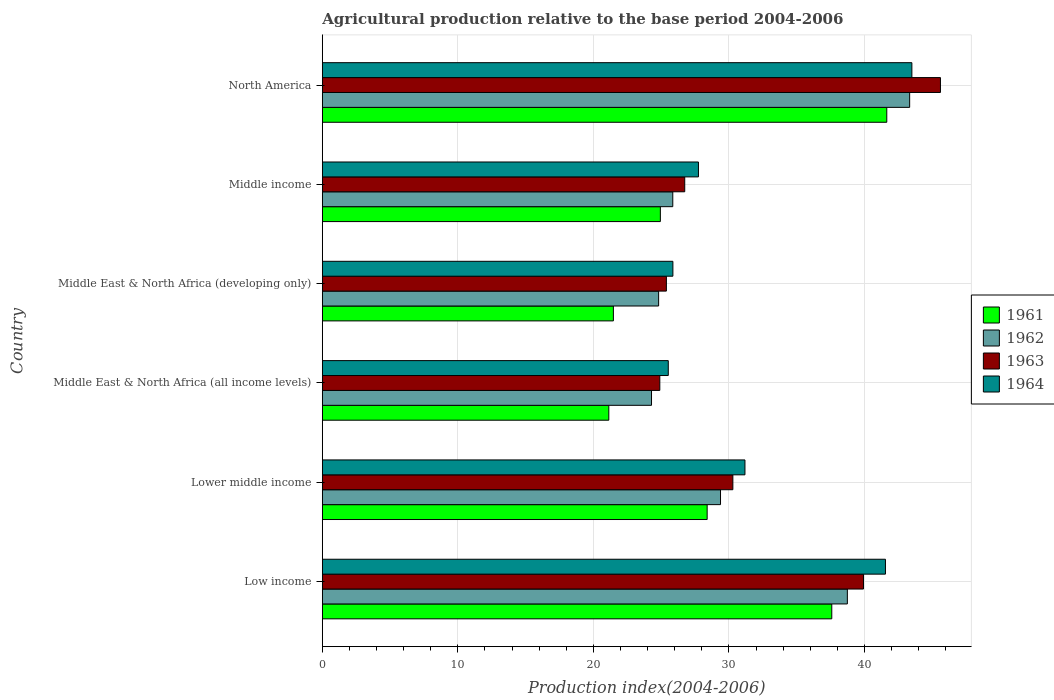How many bars are there on the 6th tick from the top?
Make the answer very short. 4. What is the label of the 2nd group of bars from the top?
Offer a terse response. Middle income. In how many cases, is the number of bars for a given country not equal to the number of legend labels?
Provide a succinct answer. 0. What is the agricultural production index in 1963 in Middle East & North Africa (all income levels)?
Keep it short and to the point. 24.9. Across all countries, what is the maximum agricultural production index in 1961?
Offer a very short reply. 41.65. Across all countries, what is the minimum agricultural production index in 1964?
Your answer should be compact. 25.53. In which country was the agricultural production index in 1964 maximum?
Provide a short and direct response. North America. In which country was the agricultural production index in 1963 minimum?
Make the answer very short. Middle East & North Africa (all income levels). What is the total agricultural production index in 1964 in the graph?
Provide a succinct answer. 195.37. What is the difference between the agricultural production index in 1964 in Middle income and that in North America?
Your response must be concise. -15.75. What is the difference between the agricultural production index in 1963 in Middle income and the agricultural production index in 1962 in Low income?
Ensure brevity in your answer.  -12. What is the average agricultural production index in 1963 per country?
Offer a terse response. 32.14. What is the difference between the agricultural production index in 1961 and agricultural production index in 1963 in Middle East & North Africa (all income levels)?
Provide a succinct answer. -3.76. In how many countries, is the agricultural production index in 1961 greater than 24 ?
Offer a very short reply. 4. What is the ratio of the agricultural production index in 1961 in Low income to that in Middle East & North Africa (all income levels)?
Provide a succinct answer. 1.78. Is the agricultural production index in 1963 in Middle East & North Africa (developing only) less than that in Middle income?
Provide a short and direct response. Yes. What is the difference between the highest and the second highest agricultural production index in 1964?
Offer a terse response. 1.95. What is the difference between the highest and the lowest agricultural production index in 1964?
Your answer should be very brief. 17.97. In how many countries, is the agricultural production index in 1963 greater than the average agricultural production index in 1963 taken over all countries?
Ensure brevity in your answer.  2. Is it the case that in every country, the sum of the agricultural production index in 1961 and agricultural production index in 1963 is greater than the sum of agricultural production index in 1964 and agricultural production index in 1962?
Give a very brief answer. No. What does the 1st bar from the top in Middle East & North Africa (developing only) represents?
Make the answer very short. 1964. What does the 2nd bar from the bottom in North America represents?
Make the answer very short. 1962. Is it the case that in every country, the sum of the agricultural production index in 1961 and agricultural production index in 1964 is greater than the agricultural production index in 1963?
Your answer should be compact. Yes. How many countries are there in the graph?
Offer a terse response. 6. Are the values on the major ticks of X-axis written in scientific E-notation?
Make the answer very short. No. Does the graph contain grids?
Make the answer very short. Yes. What is the title of the graph?
Offer a terse response. Agricultural production relative to the base period 2004-2006. Does "2003" appear as one of the legend labels in the graph?
Provide a succinct answer. No. What is the label or title of the X-axis?
Provide a short and direct response. Production index(2004-2006). What is the label or title of the Y-axis?
Your answer should be very brief. Country. What is the Production index(2004-2006) of 1961 in Low income?
Ensure brevity in your answer.  37.59. What is the Production index(2004-2006) in 1962 in Low income?
Keep it short and to the point. 38.74. What is the Production index(2004-2006) of 1963 in Low income?
Your answer should be very brief. 39.93. What is the Production index(2004-2006) of 1964 in Low income?
Provide a short and direct response. 41.55. What is the Production index(2004-2006) in 1961 in Lower middle income?
Provide a succinct answer. 28.39. What is the Production index(2004-2006) of 1962 in Lower middle income?
Provide a short and direct response. 29.38. What is the Production index(2004-2006) in 1963 in Lower middle income?
Your answer should be compact. 30.29. What is the Production index(2004-2006) in 1964 in Lower middle income?
Provide a short and direct response. 31.18. What is the Production index(2004-2006) of 1961 in Middle East & North Africa (all income levels)?
Ensure brevity in your answer.  21.14. What is the Production index(2004-2006) in 1962 in Middle East & North Africa (all income levels)?
Offer a very short reply. 24.29. What is the Production index(2004-2006) in 1963 in Middle East & North Africa (all income levels)?
Make the answer very short. 24.9. What is the Production index(2004-2006) in 1964 in Middle East & North Africa (all income levels)?
Provide a short and direct response. 25.53. What is the Production index(2004-2006) of 1961 in Middle East & North Africa (developing only)?
Offer a very short reply. 21.48. What is the Production index(2004-2006) of 1962 in Middle East & North Africa (developing only)?
Provide a short and direct response. 24.81. What is the Production index(2004-2006) of 1963 in Middle East & North Africa (developing only)?
Keep it short and to the point. 25.39. What is the Production index(2004-2006) in 1964 in Middle East & North Africa (developing only)?
Ensure brevity in your answer.  25.86. What is the Production index(2004-2006) in 1961 in Middle income?
Provide a short and direct response. 24.94. What is the Production index(2004-2006) in 1962 in Middle income?
Your response must be concise. 25.86. What is the Production index(2004-2006) in 1963 in Middle income?
Your answer should be compact. 26.74. What is the Production index(2004-2006) of 1964 in Middle income?
Give a very brief answer. 27.75. What is the Production index(2004-2006) of 1961 in North America?
Give a very brief answer. 41.65. What is the Production index(2004-2006) of 1962 in North America?
Provide a short and direct response. 43.33. What is the Production index(2004-2006) in 1963 in North America?
Make the answer very short. 45.61. What is the Production index(2004-2006) of 1964 in North America?
Provide a short and direct response. 43.5. Across all countries, what is the maximum Production index(2004-2006) of 1961?
Make the answer very short. 41.65. Across all countries, what is the maximum Production index(2004-2006) of 1962?
Your response must be concise. 43.33. Across all countries, what is the maximum Production index(2004-2006) of 1963?
Provide a short and direct response. 45.61. Across all countries, what is the maximum Production index(2004-2006) of 1964?
Your answer should be compact. 43.5. Across all countries, what is the minimum Production index(2004-2006) of 1961?
Offer a terse response. 21.14. Across all countries, what is the minimum Production index(2004-2006) of 1962?
Your answer should be very brief. 24.29. Across all countries, what is the minimum Production index(2004-2006) of 1963?
Your answer should be compact. 24.9. Across all countries, what is the minimum Production index(2004-2006) in 1964?
Give a very brief answer. 25.53. What is the total Production index(2004-2006) in 1961 in the graph?
Offer a very short reply. 175.18. What is the total Production index(2004-2006) of 1962 in the graph?
Make the answer very short. 186.41. What is the total Production index(2004-2006) in 1963 in the graph?
Ensure brevity in your answer.  192.85. What is the total Production index(2004-2006) of 1964 in the graph?
Provide a short and direct response. 195.37. What is the difference between the Production index(2004-2006) of 1961 in Low income and that in Lower middle income?
Offer a very short reply. 9.19. What is the difference between the Production index(2004-2006) of 1962 in Low income and that in Lower middle income?
Your answer should be compact. 9.36. What is the difference between the Production index(2004-2006) of 1963 in Low income and that in Lower middle income?
Ensure brevity in your answer.  9.64. What is the difference between the Production index(2004-2006) of 1964 in Low income and that in Lower middle income?
Your answer should be very brief. 10.37. What is the difference between the Production index(2004-2006) in 1961 in Low income and that in Middle East & North Africa (all income levels)?
Provide a succinct answer. 16.45. What is the difference between the Production index(2004-2006) of 1962 in Low income and that in Middle East & North Africa (all income levels)?
Ensure brevity in your answer.  14.45. What is the difference between the Production index(2004-2006) of 1963 in Low income and that in Middle East & North Africa (all income levels)?
Your answer should be compact. 15.03. What is the difference between the Production index(2004-2006) in 1964 in Low income and that in Middle East & North Africa (all income levels)?
Keep it short and to the point. 16.02. What is the difference between the Production index(2004-2006) of 1961 in Low income and that in Middle East & North Africa (developing only)?
Your answer should be compact. 16.11. What is the difference between the Production index(2004-2006) of 1962 in Low income and that in Middle East & North Africa (developing only)?
Provide a short and direct response. 13.93. What is the difference between the Production index(2004-2006) in 1963 in Low income and that in Middle East & North Africa (developing only)?
Provide a short and direct response. 14.54. What is the difference between the Production index(2004-2006) in 1964 in Low income and that in Middle East & North Africa (developing only)?
Ensure brevity in your answer.  15.68. What is the difference between the Production index(2004-2006) in 1961 in Low income and that in Middle income?
Your answer should be compact. 12.65. What is the difference between the Production index(2004-2006) in 1962 in Low income and that in Middle income?
Make the answer very short. 12.88. What is the difference between the Production index(2004-2006) in 1963 in Low income and that in Middle income?
Your response must be concise. 13.19. What is the difference between the Production index(2004-2006) in 1964 in Low income and that in Middle income?
Your answer should be very brief. 13.8. What is the difference between the Production index(2004-2006) in 1961 in Low income and that in North America?
Provide a succinct answer. -4.06. What is the difference between the Production index(2004-2006) of 1962 in Low income and that in North America?
Offer a very short reply. -4.6. What is the difference between the Production index(2004-2006) in 1963 in Low income and that in North America?
Your response must be concise. -5.68. What is the difference between the Production index(2004-2006) of 1964 in Low income and that in North America?
Offer a very short reply. -1.95. What is the difference between the Production index(2004-2006) in 1961 in Lower middle income and that in Middle East & North Africa (all income levels)?
Keep it short and to the point. 7.26. What is the difference between the Production index(2004-2006) of 1962 in Lower middle income and that in Middle East & North Africa (all income levels)?
Ensure brevity in your answer.  5.09. What is the difference between the Production index(2004-2006) of 1963 in Lower middle income and that in Middle East & North Africa (all income levels)?
Your answer should be very brief. 5.39. What is the difference between the Production index(2004-2006) in 1964 in Lower middle income and that in Middle East & North Africa (all income levels)?
Offer a very short reply. 5.66. What is the difference between the Production index(2004-2006) in 1961 in Lower middle income and that in Middle East & North Africa (developing only)?
Provide a succinct answer. 6.92. What is the difference between the Production index(2004-2006) in 1962 in Lower middle income and that in Middle East & North Africa (developing only)?
Offer a very short reply. 4.57. What is the difference between the Production index(2004-2006) of 1963 in Lower middle income and that in Middle East & North Africa (developing only)?
Your answer should be very brief. 4.9. What is the difference between the Production index(2004-2006) in 1964 in Lower middle income and that in Middle East & North Africa (developing only)?
Your answer should be very brief. 5.32. What is the difference between the Production index(2004-2006) in 1961 in Lower middle income and that in Middle income?
Make the answer very short. 3.45. What is the difference between the Production index(2004-2006) of 1962 in Lower middle income and that in Middle income?
Provide a succinct answer. 3.52. What is the difference between the Production index(2004-2006) of 1963 in Lower middle income and that in Middle income?
Offer a very short reply. 3.55. What is the difference between the Production index(2004-2006) in 1964 in Lower middle income and that in Middle income?
Your answer should be very brief. 3.43. What is the difference between the Production index(2004-2006) in 1961 in Lower middle income and that in North America?
Your response must be concise. -13.25. What is the difference between the Production index(2004-2006) in 1962 in Lower middle income and that in North America?
Keep it short and to the point. -13.96. What is the difference between the Production index(2004-2006) of 1963 in Lower middle income and that in North America?
Ensure brevity in your answer.  -15.32. What is the difference between the Production index(2004-2006) of 1964 in Lower middle income and that in North America?
Offer a terse response. -12.32. What is the difference between the Production index(2004-2006) in 1961 in Middle East & North Africa (all income levels) and that in Middle East & North Africa (developing only)?
Offer a very short reply. -0.34. What is the difference between the Production index(2004-2006) in 1962 in Middle East & North Africa (all income levels) and that in Middle East & North Africa (developing only)?
Provide a succinct answer. -0.52. What is the difference between the Production index(2004-2006) in 1963 in Middle East & North Africa (all income levels) and that in Middle East & North Africa (developing only)?
Ensure brevity in your answer.  -0.48. What is the difference between the Production index(2004-2006) in 1964 in Middle East & North Africa (all income levels) and that in Middle East & North Africa (developing only)?
Offer a very short reply. -0.34. What is the difference between the Production index(2004-2006) of 1961 in Middle East & North Africa (all income levels) and that in Middle income?
Your answer should be very brief. -3.8. What is the difference between the Production index(2004-2006) in 1962 in Middle East & North Africa (all income levels) and that in Middle income?
Make the answer very short. -1.57. What is the difference between the Production index(2004-2006) in 1963 in Middle East & North Africa (all income levels) and that in Middle income?
Your response must be concise. -1.84. What is the difference between the Production index(2004-2006) of 1964 in Middle East & North Africa (all income levels) and that in Middle income?
Offer a very short reply. -2.23. What is the difference between the Production index(2004-2006) in 1961 in Middle East & North Africa (all income levels) and that in North America?
Your response must be concise. -20.51. What is the difference between the Production index(2004-2006) in 1962 in Middle East & North Africa (all income levels) and that in North America?
Provide a short and direct response. -19.05. What is the difference between the Production index(2004-2006) in 1963 in Middle East & North Africa (all income levels) and that in North America?
Your answer should be very brief. -20.71. What is the difference between the Production index(2004-2006) in 1964 in Middle East & North Africa (all income levels) and that in North America?
Give a very brief answer. -17.97. What is the difference between the Production index(2004-2006) in 1961 in Middle East & North Africa (developing only) and that in Middle income?
Provide a short and direct response. -3.47. What is the difference between the Production index(2004-2006) of 1962 in Middle East & North Africa (developing only) and that in Middle income?
Provide a succinct answer. -1.04. What is the difference between the Production index(2004-2006) of 1963 in Middle East & North Africa (developing only) and that in Middle income?
Offer a terse response. -1.35. What is the difference between the Production index(2004-2006) in 1964 in Middle East & North Africa (developing only) and that in Middle income?
Keep it short and to the point. -1.89. What is the difference between the Production index(2004-2006) of 1961 in Middle East & North Africa (developing only) and that in North America?
Make the answer very short. -20.17. What is the difference between the Production index(2004-2006) of 1962 in Middle East & North Africa (developing only) and that in North America?
Offer a terse response. -18.52. What is the difference between the Production index(2004-2006) in 1963 in Middle East & North Africa (developing only) and that in North America?
Your answer should be compact. -20.22. What is the difference between the Production index(2004-2006) of 1964 in Middle East & North Africa (developing only) and that in North America?
Give a very brief answer. -17.63. What is the difference between the Production index(2004-2006) in 1961 in Middle income and that in North America?
Keep it short and to the point. -16.71. What is the difference between the Production index(2004-2006) of 1962 in Middle income and that in North America?
Offer a terse response. -17.48. What is the difference between the Production index(2004-2006) in 1963 in Middle income and that in North America?
Your answer should be very brief. -18.87. What is the difference between the Production index(2004-2006) of 1964 in Middle income and that in North America?
Your answer should be very brief. -15.75. What is the difference between the Production index(2004-2006) in 1961 in Low income and the Production index(2004-2006) in 1962 in Lower middle income?
Provide a succinct answer. 8.21. What is the difference between the Production index(2004-2006) of 1961 in Low income and the Production index(2004-2006) of 1963 in Lower middle income?
Give a very brief answer. 7.3. What is the difference between the Production index(2004-2006) in 1961 in Low income and the Production index(2004-2006) in 1964 in Lower middle income?
Provide a succinct answer. 6.41. What is the difference between the Production index(2004-2006) in 1962 in Low income and the Production index(2004-2006) in 1963 in Lower middle income?
Offer a terse response. 8.45. What is the difference between the Production index(2004-2006) of 1962 in Low income and the Production index(2004-2006) of 1964 in Lower middle income?
Your response must be concise. 7.56. What is the difference between the Production index(2004-2006) of 1963 in Low income and the Production index(2004-2006) of 1964 in Lower middle income?
Offer a very short reply. 8.75. What is the difference between the Production index(2004-2006) in 1961 in Low income and the Production index(2004-2006) in 1962 in Middle East & North Africa (all income levels)?
Your response must be concise. 13.3. What is the difference between the Production index(2004-2006) of 1961 in Low income and the Production index(2004-2006) of 1963 in Middle East & North Africa (all income levels)?
Offer a very short reply. 12.69. What is the difference between the Production index(2004-2006) in 1961 in Low income and the Production index(2004-2006) in 1964 in Middle East & North Africa (all income levels)?
Make the answer very short. 12.06. What is the difference between the Production index(2004-2006) in 1962 in Low income and the Production index(2004-2006) in 1963 in Middle East & North Africa (all income levels)?
Make the answer very short. 13.84. What is the difference between the Production index(2004-2006) in 1962 in Low income and the Production index(2004-2006) in 1964 in Middle East & North Africa (all income levels)?
Provide a short and direct response. 13.21. What is the difference between the Production index(2004-2006) in 1963 in Low income and the Production index(2004-2006) in 1964 in Middle East & North Africa (all income levels)?
Your answer should be very brief. 14.4. What is the difference between the Production index(2004-2006) of 1961 in Low income and the Production index(2004-2006) of 1962 in Middle East & North Africa (developing only)?
Ensure brevity in your answer.  12.78. What is the difference between the Production index(2004-2006) of 1961 in Low income and the Production index(2004-2006) of 1963 in Middle East & North Africa (developing only)?
Give a very brief answer. 12.2. What is the difference between the Production index(2004-2006) of 1961 in Low income and the Production index(2004-2006) of 1964 in Middle East & North Africa (developing only)?
Make the answer very short. 11.72. What is the difference between the Production index(2004-2006) of 1962 in Low income and the Production index(2004-2006) of 1963 in Middle East & North Africa (developing only)?
Ensure brevity in your answer.  13.35. What is the difference between the Production index(2004-2006) of 1962 in Low income and the Production index(2004-2006) of 1964 in Middle East & North Africa (developing only)?
Ensure brevity in your answer.  12.87. What is the difference between the Production index(2004-2006) in 1963 in Low income and the Production index(2004-2006) in 1964 in Middle East & North Africa (developing only)?
Give a very brief answer. 14.06. What is the difference between the Production index(2004-2006) of 1961 in Low income and the Production index(2004-2006) of 1962 in Middle income?
Offer a terse response. 11.73. What is the difference between the Production index(2004-2006) of 1961 in Low income and the Production index(2004-2006) of 1963 in Middle income?
Your answer should be very brief. 10.85. What is the difference between the Production index(2004-2006) in 1961 in Low income and the Production index(2004-2006) in 1964 in Middle income?
Provide a short and direct response. 9.84. What is the difference between the Production index(2004-2006) in 1962 in Low income and the Production index(2004-2006) in 1963 in Middle income?
Your answer should be very brief. 12. What is the difference between the Production index(2004-2006) of 1962 in Low income and the Production index(2004-2006) of 1964 in Middle income?
Your response must be concise. 10.99. What is the difference between the Production index(2004-2006) in 1963 in Low income and the Production index(2004-2006) in 1964 in Middle income?
Keep it short and to the point. 12.18. What is the difference between the Production index(2004-2006) in 1961 in Low income and the Production index(2004-2006) in 1962 in North America?
Your answer should be very brief. -5.75. What is the difference between the Production index(2004-2006) in 1961 in Low income and the Production index(2004-2006) in 1963 in North America?
Your answer should be compact. -8.02. What is the difference between the Production index(2004-2006) in 1961 in Low income and the Production index(2004-2006) in 1964 in North America?
Make the answer very short. -5.91. What is the difference between the Production index(2004-2006) in 1962 in Low income and the Production index(2004-2006) in 1963 in North America?
Keep it short and to the point. -6.87. What is the difference between the Production index(2004-2006) in 1962 in Low income and the Production index(2004-2006) in 1964 in North America?
Provide a succinct answer. -4.76. What is the difference between the Production index(2004-2006) in 1963 in Low income and the Production index(2004-2006) in 1964 in North America?
Give a very brief answer. -3.57. What is the difference between the Production index(2004-2006) of 1961 in Lower middle income and the Production index(2004-2006) of 1962 in Middle East & North Africa (all income levels)?
Provide a succinct answer. 4.11. What is the difference between the Production index(2004-2006) in 1961 in Lower middle income and the Production index(2004-2006) in 1963 in Middle East & North Africa (all income levels)?
Your answer should be very brief. 3.49. What is the difference between the Production index(2004-2006) of 1961 in Lower middle income and the Production index(2004-2006) of 1964 in Middle East & North Africa (all income levels)?
Offer a very short reply. 2.87. What is the difference between the Production index(2004-2006) in 1962 in Lower middle income and the Production index(2004-2006) in 1963 in Middle East & North Africa (all income levels)?
Provide a short and direct response. 4.48. What is the difference between the Production index(2004-2006) in 1962 in Lower middle income and the Production index(2004-2006) in 1964 in Middle East & North Africa (all income levels)?
Your response must be concise. 3.85. What is the difference between the Production index(2004-2006) in 1963 in Lower middle income and the Production index(2004-2006) in 1964 in Middle East & North Africa (all income levels)?
Provide a succinct answer. 4.76. What is the difference between the Production index(2004-2006) of 1961 in Lower middle income and the Production index(2004-2006) of 1962 in Middle East & North Africa (developing only)?
Offer a terse response. 3.58. What is the difference between the Production index(2004-2006) in 1961 in Lower middle income and the Production index(2004-2006) in 1963 in Middle East & North Africa (developing only)?
Provide a succinct answer. 3.01. What is the difference between the Production index(2004-2006) in 1961 in Lower middle income and the Production index(2004-2006) in 1964 in Middle East & North Africa (developing only)?
Provide a short and direct response. 2.53. What is the difference between the Production index(2004-2006) of 1962 in Lower middle income and the Production index(2004-2006) of 1963 in Middle East & North Africa (developing only)?
Your answer should be very brief. 3.99. What is the difference between the Production index(2004-2006) of 1962 in Lower middle income and the Production index(2004-2006) of 1964 in Middle East & North Africa (developing only)?
Ensure brevity in your answer.  3.51. What is the difference between the Production index(2004-2006) in 1963 in Lower middle income and the Production index(2004-2006) in 1964 in Middle East & North Africa (developing only)?
Make the answer very short. 4.43. What is the difference between the Production index(2004-2006) of 1961 in Lower middle income and the Production index(2004-2006) of 1962 in Middle income?
Ensure brevity in your answer.  2.54. What is the difference between the Production index(2004-2006) of 1961 in Lower middle income and the Production index(2004-2006) of 1963 in Middle income?
Make the answer very short. 1.65. What is the difference between the Production index(2004-2006) in 1961 in Lower middle income and the Production index(2004-2006) in 1964 in Middle income?
Make the answer very short. 0.64. What is the difference between the Production index(2004-2006) of 1962 in Lower middle income and the Production index(2004-2006) of 1963 in Middle income?
Keep it short and to the point. 2.64. What is the difference between the Production index(2004-2006) of 1962 in Lower middle income and the Production index(2004-2006) of 1964 in Middle income?
Offer a very short reply. 1.63. What is the difference between the Production index(2004-2006) of 1963 in Lower middle income and the Production index(2004-2006) of 1964 in Middle income?
Ensure brevity in your answer.  2.54. What is the difference between the Production index(2004-2006) in 1961 in Lower middle income and the Production index(2004-2006) in 1962 in North America?
Your answer should be compact. -14.94. What is the difference between the Production index(2004-2006) of 1961 in Lower middle income and the Production index(2004-2006) of 1963 in North America?
Ensure brevity in your answer.  -17.21. What is the difference between the Production index(2004-2006) in 1961 in Lower middle income and the Production index(2004-2006) in 1964 in North America?
Give a very brief answer. -15.1. What is the difference between the Production index(2004-2006) in 1962 in Lower middle income and the Production index(2004-2006) in 1963 in North America?
Ensure brevity in your answer.  -16.23. What is the difference between the Production index(2004-2006) of 1962 in Lower middle income and the Production index(2004-2006) of 1964 in North America?
Provide a succinct answer. -14.12. What is the difference between the Production index(2004-2006) in 1963 in Lower middle income and the Production index(2004-2006) in 1964 in North America?
Make the answer very short. -13.21. What is the difference between the Production index(2004-2006) in 1961 in Middle East & North Africa (all income levels) and the Production index(2004-2006) in 1962 in Middle East & North Africa (developing only)?
Provide a succinct answer. -3.68. What is the difference between the Production index(2004-2006) of 1961 in Middle East & North Africa (all income levels) and the Production index(2004-2006) of 1963 in Middle East & North Africa (developing only)?
Provide a succinct answer. -4.25. What is the difference between the Production index(2004-2006) of 1961 in Middle East & North Africa (all income levels) and the Production index(2004-2006) of 1964 in Middle East & North Africa (developing only)?
Your answer should be compact. -4.73. What is the difference between the Production index(2004-2006) in 1962 in Middle East & North Africa (all income levels) and the Production index(2004-2006) in 1963 in Middle East & North Africa (developing only)?
Your response must be concise. -1.1. What is the difference between the Production index(2004-2006) in 1962 in Middle East & North Africa (all income levels) and the Production index(2004-2006) in 1964 in Middle East & North Africa (developing only)?
Your answer should be compact. -1.58. What is the difference between the Production index(2004-2006) in 1963 in Middle East & North Africa (all income levels) and the Production index(2004-2006) in 1964 in Middle East & North Africa (developing only)?
Your answer should be very brief. -0.96. What is the difference between the Production index(2004-2006) in 1961 in Middle East & North Africa (all income levels) and the Production index(2004-2006) in 1962 in Middle income?
Offer a very short reply. -4.72. What is the difference between the Production index(2004-2006) of 1961 in Middle East & North Africa (all income levels) and the Production index(2004-2006) of 1963 in Middle income?
Offer a terse response. -5.6. What is the difference between the Production index(2004-2006) of 1961 in Middle East & North Africa (all income levels) and the Production index(2004-2006) of 1964 in Middle income?
Provide a succinct answer. -6.61. What is the difference between the Production index(2004-2006) in 1962 in Middle East & North Africa (all income levels) and the Production index(2004-2006) in 1963 in Middle income?
Your answer should be very brief. -2.45. What is the difference between the Production index(2004-2006) of 1962 in Middle East & North Africa (all income levels) and the Production index(2004-2006) of 1964 in Middle income?
Offer a very short reply. -3.46. What is the difference between the Production index(2004-2006) of 1963 in Middle East & North Africa (all income levels) and the Production index(2004-2006) of 1964 in Middle income?
Your response must be concise. -2.85. What is the difference between the Production index(2004-2006) in 1961 in Middle East & North Africa (all income levels) and the Production index(2004-2006) in 1962 in North America?
Your response must be concise. -22.2. What is the difference between the Production index(2004-2006) of 1961 in Middle East & North Africa (all income levels) and the Production index(2004-2006) of 1963 in North America?
Give a very brief answer. -24.47. What is the difference between the Production index(2004-2006) of 1961 in Middle East & North Africa (all income levels) and the Production index(2004-2006) of 1964 in North America?
Make the answer very short. -22.36. What is the difference between the Production index(2004-2006) of 1962 in Middle East & North Africa (all income levels) and the Production index(2004-2006) of 1963 in North America?
Your answer should be compact. -21.32. What is the difference between the Production index(2004-2006) of 1962 in Middle East & North Africa (all income levels) and the Production index(2004-2006) of 1964 in North America?
Your answer should be compact. -19.21. What is the difference between the Production index(2004-2006) of 1963 in Middle East & North Africa (all income levels) and the Production index(2004-2006) of 1964 in North America?
Provide a succinct answer. -18.6. What is the difference between the Production index(2004-2006) of 1961 in Middle East & North Africa (developing only) and the Production index(2004-2006) of 1962 in Middle income?
Make the answer very short. -4.38. What is the difference between the Production index(2004-2006) of 1961 in Middle East & North Africa (developing only) and the Production index(2004-2006) of 1963 in Middle income?
Provide a succinct answer. -5.26. What is the difference between the Production index(2004-2006) in 1961 in Middle East & North Africa (developing only) and the Production index(2004-2006) in 1964 in Middle income?
Keep it short and to the point. -6.28. What is the difference between the Production index(2004-2006) in 1962 in Middle East & North Africa (developing only) and the Production index(2004-2006) in 1963 in Middle income?
Offer a very short reply. -1.93. What is the difference between the Production index(2004-2006) in 1962 in Middle East & North Africa (developing only) and the Production index(2004-2006) in 1964 in Middle income?
Make the answer very short. -2.94. What is the difference between the Production index(2004-2006) of 1963 in Middle East & North Africa (developing only) and the Production index(2004-2006) of 1964 in Middle income?
Provide a short and direct response. -2.37. What is the difference between the Production index(2004-2006) in 1961 in Middle East & North Africa (developing only) and the Production index(2004-2006) in 1962 in North America?
Ensure brevity in your answer.  -21.86. What is the difference between the Production index(2004-2006) in 1961 in Middle East & North Africa (developing only) and the Production index(2004-2006) in 1963 in North America?
Ensure brevity in your answer.  -24.13. What is the difference between the Production index(2004-2006) of 1961 in Middle East & North Africa (developing only) and the Production index(2004-2006) of 1964 in North America?
Provide a short and direct response. -22.02. What is the difference between the Production index(2004-2006) in 1962 in Middle East & North Africa (developing only) and the Production index(2004-2006) in 1963 in North America?
Your answer should be compact. -20.79. What is the difference between the Production index(2004-2006) of 1962 in Middle East & North Africa (developing only) and the Production index(2004-2006) of 1964 in North America?
Your answer should be very brief. -18.69. What is the difference between the Production index(2004-2006) in 1963 in Middle East & North Africa (developing only) and the Production index(2004-2006) in 1964 in North America?
Make the answer very short. -18.11. What is the difference between the Production index(2004-2006) in 1961 in Middle income and the Production index(2004-2006) in 1962 in North America?
Your answer should be very brief. -18.39. What is the difference between the Production index(2004-2006) of 1961 in Middle income and the Production index(2004-2006) of 1963 in North America?
Keep it short and to the point. -20.67. What is the difference between the Production index(2004-2006) in 1961 in Middle income and the Production index(2004-2006) in 1964 in North America?
Offer a very short reply. -18.56. What is the difference between the Production index(2004-2006) in 1962 in Middle income and the Production index(2004-2006) in 1963 in North America?
Ensure brevity in your answer.  -19.75. What is the difference between the Production index(2004-2006) in 1962 in Middle income and the Production index(2004-2006) in 1964 in North America?
Offer a very short reply. -17.64. What is the difference between the Production index(2004-2006) of 1963 in Middle income and the Production index(2004-2006) of 1964 in North America?
Make the answer very short. -16.76. What is the average Production index(2004-2006) in 1961 per country?
Provide a short and direct response. 29.2. What is the average Production index(2004-2006) in 1962 per country?
Offer a terse response. 31.07. What is the average Production index(2004-2006) of 1963 per country?
Give a very brief answer. 32.14. What is the average Production index(2004-2006) in 1964 per country?
Make the answer very short. 32.56. What is the difference between the Production index(2004-2006) in 1961 and Production index(2004-2006) in 1962 in Low income?
Give a very brief answer. -1.15. What is the difference between the Production index(2004-2006) in 1961 and Production index(2004-2006) in 1963 in Low income?
Offer a very short reply. -2.34. What is the difference between the Production index(2004-2006) in 1961 and Production index(2004-2006) in 1964 in Low income?
Your answer should be compact. -3.96. What is the difference between the Production index(2004-2006) in 1962 and Production index(2004-2006) in 1963 in Low income?
Make the answer very short. -1.19. What is the difference between the Production index(2004-2006) in 1962 and Production index(2004-2006) in 1964 in Low income?
Provide a short and direct response. -2.81. What is the difference between the Production index(2004-2006) of 1963 and Production index(2004-2006) of 1964 in Low income?
Offer a terse response. -1.62. What is the difference between the Production index(2004-2006) in 1961 and Production index(2004-2006) in 1962 in Lower middle income?
Provide a succinct answer. -0.99. What is the difference between the Production index(2004-2006) in 1961 and Production index(2004-2006) in 1963 in Lower middle income?
Give a very brief answer. -1.9. What is the difference between the Production index(2004-2006) in 1961 and Production index(2004-2006) in 1964 in Lower middle income?
Your answer should be compact. -2.79. What is the difference between the Production index(2004-2006) of 1962 and Production index(2004-2006) of 1963 in Lower middle income?
Give a very brief answer. -0.91. What is the difference between the Production index(2004-2006) in 1962 and Production index(2004-2006) in 1964 in Lower middle income?
Offer a terse response. -1.8. What is the difference between the Production index(2004-2006) in 1963 and Production index(2004-2006) in 1964 in Lower middle income?
Provide a short and direct response. -0.89. What is the difference between the Production index(2004-2006) in 1961 and Production index(2004-2006) in 1962 in Middle East & North Africa (all income levels)?
Keep it short and to the point. -3.15. What is the difference between the Production index(2004-2006) of 1961 and Production index(2004-2006) of 1963 in Middle East & North Africa (all income levels)?
Offer a very short reply. -3.76. What is the difference between the Production index(2004-2006) of 1961 and Production index(2004-2006) of 1964 in Middle East & North Africa (all income levels)?
Ensure brevity in your answer.  -4.39. What is the difference between the Production index(2004-2006) of 1962 and Production index(2004-2006) of 1963 in Middle East & North Africa (all income levels)?
Your answer should be compact. -0.61. What is the difference between the Production index(2004-2006) in 1962 and Production index(2004-2006) in 1964 in Middle East & North Africa (all income levels)?
Provide a succinct answer. -1.24. What is the difference between the Production index(2004-2006) in 1963 and Production index(2004-2006) in 1964 in Middle East & North Africa (all income levels)?
Make the answer very short. -0.62. What is the difference between the Production index(2004-2006) of 1961 and Production index(2004-2006) of 1962 in Middle East & North Africa (developing only)?
Offer a terse response. -3.34. What is the difference between the Production index(2004-2006) in 1961 and Production index(2004-2006) in 1963 in Middle East & North Africa (developing only)?
Ensure brevity in your answer.  -3.91. What is the difference between the Production index(2004-2006) of 1961 and Production index(2004-2006) of 1964 in Middle East & North Africa (developing only)?
Provide a succinct answer. -4.39. What is the difference between the Production index(2004-2006) in 1962 and Production index(2004-2006) in 1963 in Middle East & North Africa (developing only)?
Ensure brevity in your answer.  -0.57. What is the difference between the Production index(2004-2006) of 1962 and Production index(2004-2006) of 1964 in Middle East & North Africa (developing only)?
Keep it short and to the point. -1.05. What is the difference between the Production index(2004-2006) in 1963 and Production index(2004-2006) in 1964 in Middle East & North Africa (developing only)?
Give a very brief answer. -0.48. What is the difference between the Production index(2004-2006) of 1961 and Production index(2004-2006) of 1962 in Middle income?
Your answer should be compact. -0.92. What is the difference between the Production index(2004-2006) of 1961 and Production index(2004-2006) of 1963 in Middle income?
Provide a short and direct response. -1.8. What is the difference between the Production index(2004-2006) in 1961 and Production index(2004-2006) in 1964 in Middle income?
Give a very brief answer. -2.81. What is the difference between the Production index(2004-2006) in 1962 and Production index(2004-2006) in 1963 in Middle income?
Offer a very short reply. -0.88. What is the difference between the Production index(2004-2006) in 1962 and Production index(2004-2006) in 1964 in Middle income?
Make the answer very short. -1.89. What is the difference between the Production index(2004-2006) of 1963 and Production index(2004-2006) of 1964 in Middle income?
Offer a very short reply. -1.01. What is the difference between the Production index(2004-2006) in 1961 and Production index(2004-2006) in 1962 in North America?
Your answer should be compact. -1.69. What is the difference between the Production index(2004-2006) in 1961 and Production index(2004-2006) in 1963 in North America?
Your answer should be very brief. -3.96. What is the difference between the Production index(2004-2006) of 1961 and Production index(2004-2006) of 1964 in North America?
Your response must be concise. -1.85. What is the difference between the Production index(2004-2006) of 1962 and Production index(2004-2006) of 1963 in North America?
Provide a short and direct response. -2.27. What is the difference between the Production index(2004-2006) of 1962 and Production index(2004-2006) of 1964 in North America?
Your answer should be very brief. -0.16. What is the difference between the Production index(2004-2006) in 1963 and Production index(2004-2006) in 1964 in North America?
Your answer should be compact. 2.11. What is the ratio of the Production index(2004-2006) in 1961 in Low income to that in Lower middle income?
Keep it short and to the point. 1.32. What is the ratio of the Production index(2004-2006) in 1962 in Low income to that in Lower middle income?
Your response must be concise. 1.32. What is the ratio of the Production index(2004-2006) in 1963 in Low income to that in Lower middle income?
Make the answer very short. 1.32. What is the ratio of the Production index(2004-2006) in 1964 in Low income to that in Lower middle income?
Your response must be concise. 1.33. What is the ratio of the Production index(2004-2006) in 1961 in Low income to that in Middle East & North Africa (all income levels)?
Ensure brevity in your answer.  1.78. What is the ratio of the Production index(2004-2006) of 1962 in Low income to that in Middle East & North Africa (all income levels)?
Your answer should be compact. 1.59. What is the ratio of the Production index(2004-2006) in 1963 in Low income to that in Middle East & North Africa (all income levels)?
Your answer should be compact. 1.6. What is the ratio of the Production index(2004-2006) of 1964 in Low income to that in Middle East & North Africa (all income levels)?
Provide a short and direct response. 1.63. What is the ratio of the Production index(2004-2006) in 1961 in Low income to that in Middle East & North Africa (developing only)?
Offer a very short reply. 1.75. What is the ratio of the Production index(2004-2006) of 1962 in Low income to that in Middle East & North Africa (developing only)?
Your answer should be very brief. 1.56. What is the ratio of the Production index(2004-2006) of 1963 in Low income to that in Middle East & North Africa (developing only)?
Make the answer very short. 1.57. What is the ratio of the Production index(2004-2006) in 1964 in Low income to that in Middle East & North Africa (developing only)?
Your answer should be very brief. 1.61. What is the ratio of the Production index(2004-2006) of 1961 in Low income to that in Middle income?
Your answer should be compact. 1.51. What is the ratio of the Production index(2004-2006) of 1962 in Low income to that in Middle income?
Ensure brevity in your answer.  1.5. What is the ratio of the Production index(2004-2006) of 1963 in Low income to that in Middle income?
Ensure brevity in your answer.  1.49. What is the ratio of the Production index(2004-2006) of 1964 in Low income to that in Middle income?
Give a very brief answer. 1.5. What is the ratio of the Production index(2004-2006) of 1961 in Low income to that in North America?
Ensure brevity in your answer.  0.9. What is the ratio of the Production index(2004-2006) of 1962 in Low income to that in North America?
Your answer should be very brief. 0.89. What is the ratio of the Production index(2004-2006) in 1963 in Low income to that in North America?
Ensure brevity in your answer.  0.88. What is the ratio of the Production index(2004-2006) in 1964 in Low income to that in North America?
Make the answer very short. 0.96. What is the ratio of the Production index(2004-2006) in 1961 in Lower middle income to that in Middle East & North Africa (all income levels)?
Offer a terse response. 1.34. What is the ratio of the Production index(2004-2006) of 1962 in Lower middle income to that in Middle East & North Africa (all income levels)?
Provide a succinct answer. 1.21. What is the ratio of the Production index(2004-2006) in 1963 in Lower middle income to that in Middle East & North Africa (all income levels)?
Give a very brief answer. 1.22. What is the ratio of the Production index(2004-2006) in 1964 in Lower middle income to that in Middle East & North Africa (all income levels)?
Offer a very short reply. 1.22. What is the ratio of the Production index(2004-2006) of 1961 in Lower middle income to that in Middle East & North Africa (developing only)?
Provide a succinct answer. 1.32. What is the ratio of the Production index(2004-2006) in 1962 in Lower middle income to that in Middle East & North Africa (developing only)?
Make the answer very short. 1.18. What is the ratio of the Production index(2004-2006) of 1963 in Lower middle income to that in Middle East & North Africa (developing only)?
Ensure brevity in your answer.  1.19. What is the ratio of the Production index(2004-2006) of 1964 in Lower middle income to that in Middle East & North Africa (developing only)?
Provide a short and direct response. 1.21. What is the ratio of the Production index(2004-2006) in 1961 in Lower middle income to that in Middle income?
Give a very brief answer. 1.14. What is the ratio of the Production index(2004-2006) in 1962 in Lower middle income to that in Middle income?
Provide a succinct answer. 1.14. What is the ratio of the Production index(2004-2006) of 1963 in Lower middle income to that in Middle income?
Make the answer very short. 1.13. What is the ratio of the Production index(2004-2006) of 1964 in Lower middle income to that in Middle income?
Give a very brief answer. 1.12. What is the ratio of the Production index(2004-2006) of 1961 in Lower middle income to that in North America?
Keep it short and to the point. 0.68. What is the ratio of the Production index(2004-2006) in 1962 in Lower middle income to that in North America?
Provide a succinct answer. 0.68. What is the ratio of the Production index(2004-2006) of 1963 in Lower middle income to that in North America?
Offer a very short reply. 0.66. What is the ratio of the Production index(2004-2006) of 1964 in Lower middle income to that in North America?
Your answer should be very brief. 0.72. What is the ratio of the Production index(2004-2006) of 1961 in Middle East & North Africa (all income levels) to that in Middle East & North Africa (developing only)?
Offer a terse response. 0.98. What is the ratio of the Production index(2004-2006) of 1962 in Middle East & North Africa (all income levels) to that in Middle East & North Africa (developing only)?
Provide a succinct answer. 0.98. What is the ratio of the Production index(2004-2006) of 1963 in Middle East & North Africa (all income levels) to that in Middle East & North Africa (developing only)?
Ensure brevity in your answer.  0.98. What is the ratio of the Production index(2004-2006) of 1964 in Middle East & North Africa (all income levels) to that in Middle East & North Africa (developing only)?
Provide a succinct answer. 0.99. What is the ratio of the Production index(2004-2006) in 1961 in Middle East & North Africa (all income levels) to that in Middle income?
Offer a terse response. 0.85. What is the ratio of the Production index(2004-2006) in 1962 in Middle East & North Africa (all income levels) to that in Middle income?
Offer a terse response. 0.94. What is the ratio of the Production index(2004-2006) of 1963 in Middle East & North Africa (all income levels) to that in Middle income?
Make the answer very short. 0.93. What is the ratio of the Production index(2004-2006) of 1964 in Middle East & North Africa (all income levels) to that in Middle income?
Offer a very short reply. 0.92. What is the ratio of the Production index(2004-2006) of 1961 in Middle East & North Africa (all income levels) to that in North America?
Provide a short and direct response. 0.51. What is the ratio of the Production index(2004-2006) in 1962 in Middle East & North Africa (all income levels) to that in North America?
Your answer should be compact. 0.56. What is the ratio of the Production index(2004-2006) of 1963 in Middle East & North Africa (all income levels) to that in North America?
Offer a very short reply. 0.55. What is the ratio of the Production index(2004-2006) in 1964 in Middle East & North Africa (all income levels) to that in North America?
Give a very brief answer. 0.59. What is the ratio of the Production index(2004-2006) in 1961 in Middle East & North Africa (developing only) to that in Middle income?
Provide a succinct answer. 0.86. What is the ratio of the Production index(2004-2006) of 1962 in Middle East & North Africa (developing only) to that in Middle income?
Make the answer very short. 0.96. What is the ratio of the Production index(2004-2006) in 1963 in Middle East & North Africa (developing only) to that in Middle income?
Your answer should be compact. 0.95. What is the ratio of the Production index(2004-2006) in 1964 in Middle East & North Africa (developing only) to that in Middle income?
Offer a very short reply. 0.93. What is the ratio of the Production index(2004-2006) of 1961 in Middle East & North Africa (developing only) to that in North America?
Offer a very short reply. 0.52. What is the ratio of the Production index(2004-2006) of 1962 in Middle East & North Africa (developing only) to that in North America?
Offer a very short reply. 0.57. What is the ratio of the Production index(2004-2006) of 1963 in Middle East & North Africa (developing only) to that in North America?
Make the answer very short. 0.56. What is the ratio of the Production index(2004-2006) of 1964 in Middle East & North Africa (developing only) to that in North America?
Your response must be concise. 0.59. What is the ratio of the Production index(2004-2006) of 1961 in Middle income to that in North America?
Provide a short and direct response. 0.6. What is the ratio of the Production index(2004-2006) of 1962 in Middle income to that in North America?
Your answer should be compact. 0.6. What is the ratio of the Production index(2004-2006) in 1963 in Middle income to that in North America?
Your response must be concise. 0.59. What is the ratio of the Production index(2004-2006) of 1964 in Middle income to that in North America?
Offer a terse response. 0.64. What is the difference between the highest and the second highest Production index(2004-2006) of 1961?
Ensure brevity in your answer.  4.06. What is the difference between the highest and the second highest Production index(2004-2006) in 1962?
Your answer should be compact. 4.6. What is the difference between the highest and the second highest Production index(2004-2006) of 1963?
Provide a short and direct response. 5.68. What is the difference between the highest and the second highest Production index(2004-2006) of 1964?
Offer a terse response. 1.95. What is the difference between the highest and the lowest Production index(2004-2006) in 1961?
Offer a terse response. 20.51. What is the difference between the highest and the lowest Production index(2004-2006) in 1962?
Offer a very short reply. 19.05. What is the difference between the highest and the lowest Production index(2004-2006) of 1963?
Offer a terse response. 20.71. What is the difference between the highest and the lowest Production index(2004-2006) of 1964?
Offer a terse response. 17.97. 